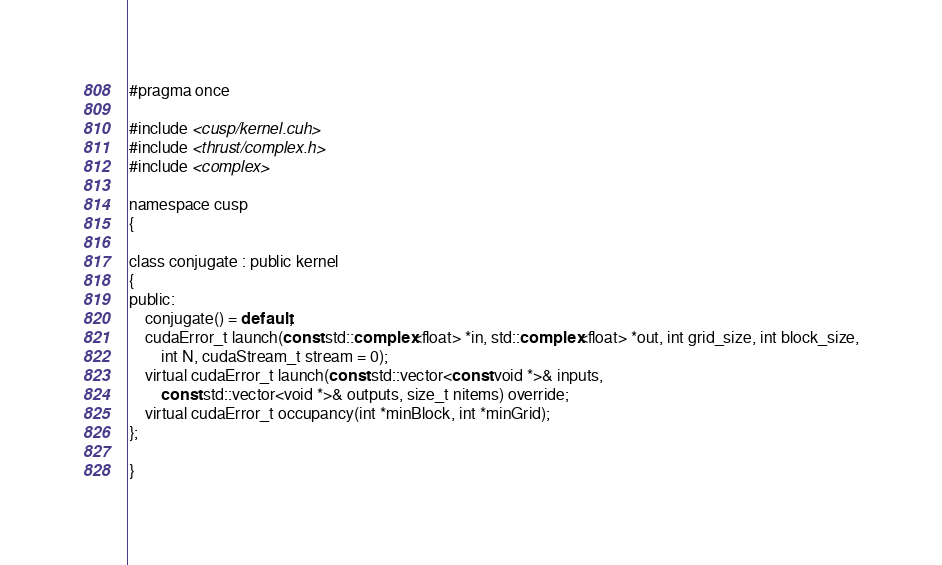Convert code to text. <code><loc_0><loc_0><loc_500><loc_500><_Cuda_>#pragma once

#include <cusp/kernel.cuh>
#include <thrust/complex.h>
#include <complex>

namespace cusp
{

class conjugate : public kernel
{
public:
    conjugate() = default;
    cudaError_t launch(const std::complex<float> *in, std::complex<float> *out, int grid_size, int block_size,
        int N, cudaStream_t stream = 0);
    virtual cudaError_t launch(const std::vector<const void *>& inputs,
        const std::vector<void *>& outputs, size_t nitems) override;
    virtual cudaError_t occupancy(int *minBlock, int *minGrid);
};

}</code> 